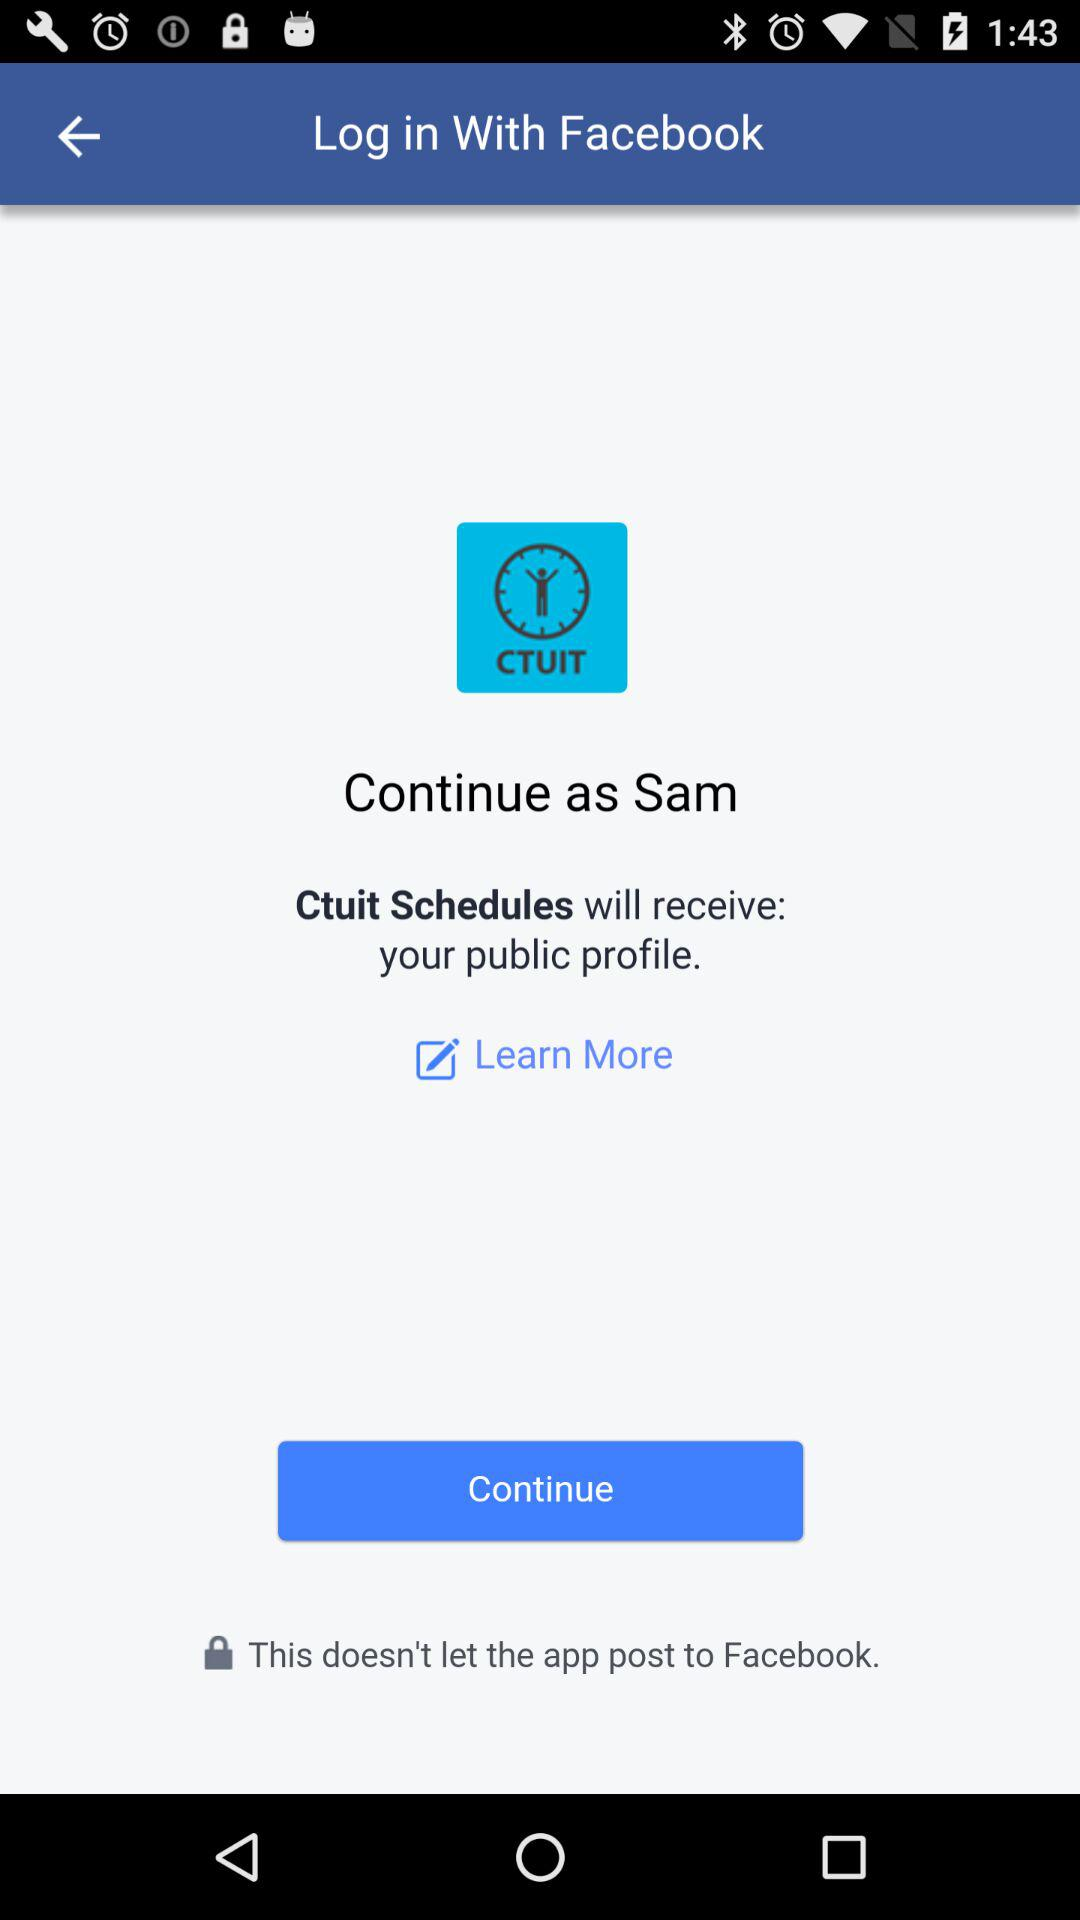What is the application name? The application names are "Facebook" and "Ctuit Schedules". 